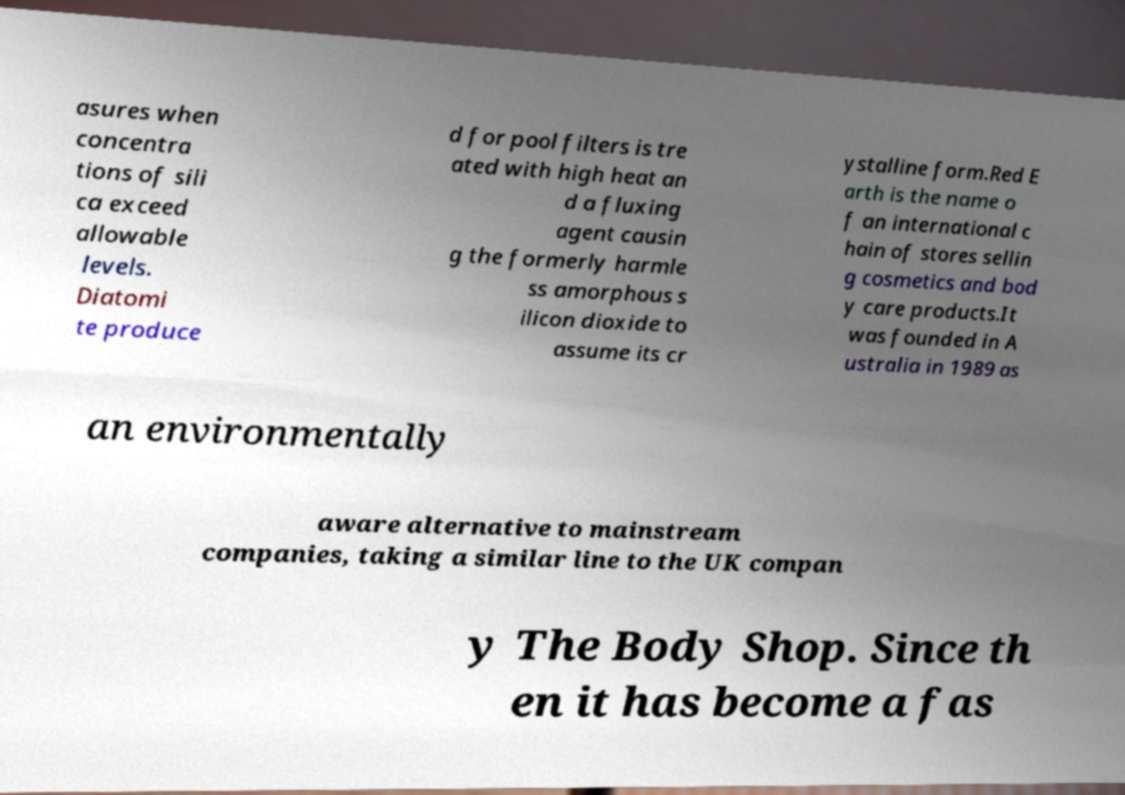What messages or text are displayed in this image? I need them in a readable, typed format. asures when concentra tions of sili ca exceed allowable levels. Diatomi te produce d for pool filters is tre ated with high heat an d a fluxing agent causin g the formerly harmle ss amorphous s ilicon dioxide to assume its cr ystalline form.Red E arth is the name o f an international c hain of stores sellin g cosmetics and bod y care products.It was founded in A ustralia in 1989 as an environmentally aware alternative to mainstream companies, taking a similar line to the UK compan y The Body Shop. Since th en it has become a fas 